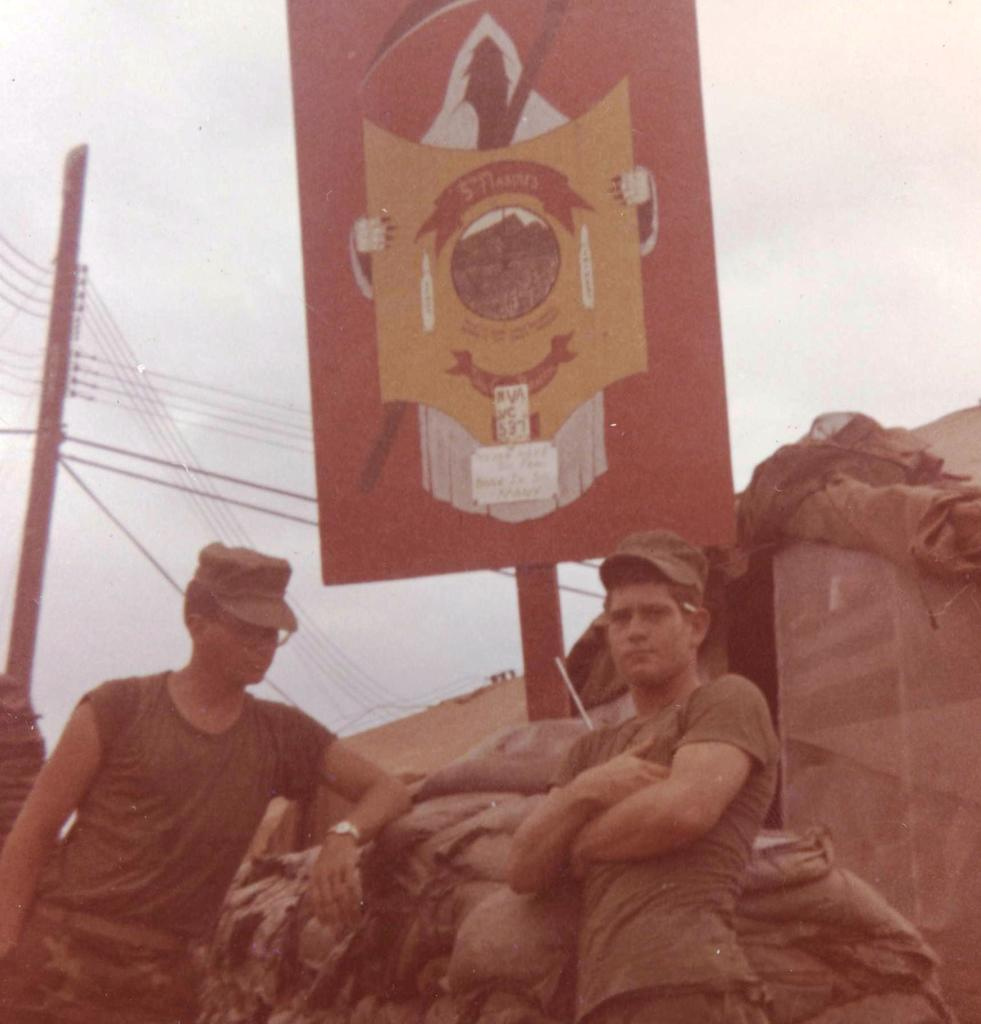How many men are in the image? There are two men in the image. What are the men wearing on their heads? The men are wearing caps. What are the men doing in the image? The men are standing. What objects can be seen in the image besides the men? There are bags, a board, wires, and a pole in the image. What is visible in the background of the image? The sky is visible in the background of the image. What type of disease can be seen affecting the men in the image? There is no indication of any disease affecting the men in the image. Can you see any snakes or ducks in the image? No, there are no snakes or ducks present in the image. 